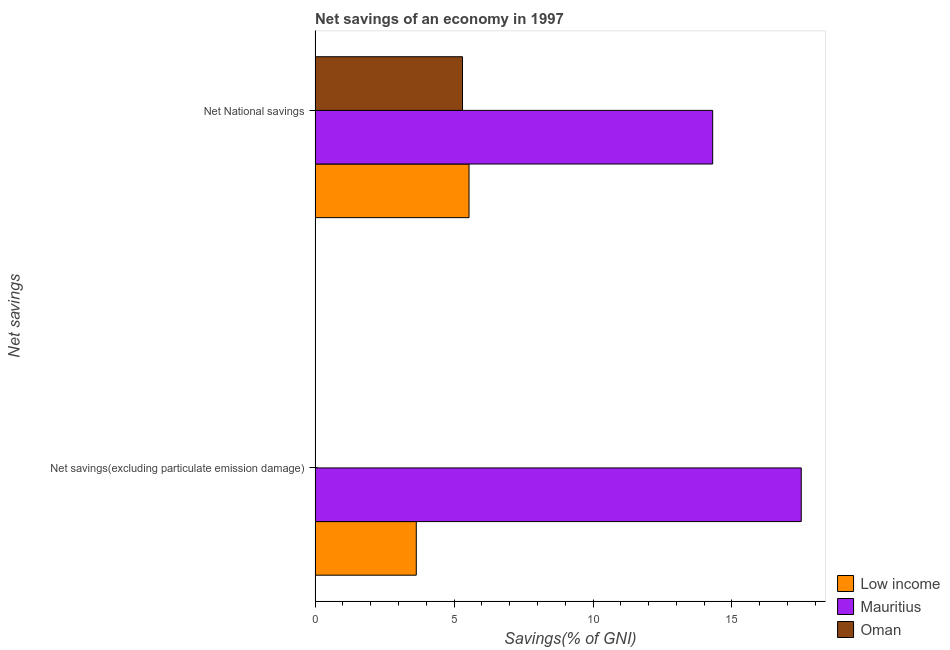How many different coloured bars are there?
Keep it short and to the point. 3. How many groups of bars are there?
Your answer should be very brief. 2. How many bars are there on the 2nd tick from the bottom?
Offer a very short reply. 3. What is the label of the 2nd group of bars from the top?
Offer a very short reply. Net savings(excluding particulate emission damage). What is the net national savings in Oman?
Your answer should be compact. 5.3. Across all countries, what is the maximum net national savings?
Keep it short and to the point. 14.31. Across all countries, what is the minimum net savings(excluding particulate emission damage)?
Your response must be concise. 0. In which country was the net savings(excluding particulate emission damage) maximum?
Your answer should be compact. Mauritius. What is the total net national savings in the graph?
Your answer should be very brief. 25.15. What is the difference between the net national savings in Oman and that in Low income?
Make the answer very short. -0.23. What is the difference between the net savings(excluding particulate emission damage) in Low income and the net national savings in Oman?
Keep it short and to the point. -1.66. What is the average net savings(excluding particulate emission damage) per country?
Provide a short and direct response. 7.04. What is the difference between the net savings(excluding particulate emission damage) and net national savings in Low income?
Provide a succinct answer. -1.9. In how many countries, is the net savings(excluding particulate emission damage) greater than 12 %?
Your response must be concise. 1. What is the ratio of the net national savings in Oman to that in Mauritius?
Your answer should be very brief. 0.37. Is the net savings(excluding particulate emission damage) in Low income less than that in Mauritius?
Offer a terse response. Yes. How many bars are there?
Offer a terse response. 5. Are all the bars in the graph horizontal?
Offer a very short reply. Yes. How many countries are there in the graph?
Offer a very short reply. 3. Are the values on the major ticks of X-axis written in scientific E-notation?
Provide a short and direct response. No. Where does the legend appear in the graph?
Offer a very short reply. Bottom right. How are the legend labels stacked?
Ensure brevity in your answer.  Vertical. What is the title of the graph?
Provide a short and direct response. Net savings of an economy in 1997. Does "Luxembourg" appear as one of the legend labels in the graph?
Offer a terse response. No. What is the label or title of the X-axis?
Provide a short and direct response. Savings(% of GNI). What is the label or title of the Y-axis?
Your answer should be very brief. Net savings. What is the Savings(% of GNI) in Low income in Net savings(excluding particulate emission damage)?
Provide a short and direct response. 3.64. What is the Savings(% of GNI) of Mauritius in Net savings(excluding particulate emission damage)?
Ensure brevity in your answer.  17.49. What is the Savings(% of GNI) in Oman in Net savings(excluding particulate emission damage)?
Keep it short and to the point. 0. What is the Savings(% of GNI) in Low income in Net National savings?
Your response must be concise. 5.54. What is the Savings(% of GNI) of Mauritius in Net National savings?
Your answer should be compact. 14.31. What is the Savings(% of GNI) in Oman in Net National savings?
Offer a terse response. 5.3. Across all Net savings, what is the maximum Savings(% of GNI) in Low income?
Keep it short and to the point. 5.54. Across all Net savings, what is the maximum Savings(% of GNI) of Mauritius?
Ensure brevity in your answer.  17.49. Across all Net savings, what is the maximum Savings(% of GNI) in Oman?
Keep it short and to the point. 5.3. Across all Net savings, what is the minimum Savings(% of GNI) in Low income?
Keep it short and to the point. 3.64. Across all Net savings, what is the minimum Savings(% of GNI) in Mauritius?
Keep it short and to the point. 14.31. Across all Net savings, what is the minimum Savings(% of GNI) of Oman?
Ensure brevity in your answer.  0. What is the total Savings(% of GNI) in Low income in the graph?
Ensure brevity in your answer.  9.18. What is the total Savings(% of GNI) of Mauritius in the graph?
Offer a very short reply. 31.8. What is the total Savings(% of GNI) in Oman in the graph?
Ensure brevity in your answer.  5.3. What is the difference between the Savings(% of GNI) of Low income in Net savings(excluding particulate emission damage) and that in Net National savings?
Your response must be concise. -1.9. What is the difference between the Savings(% of GNI) in Mauritius in Net savings(excluding particulate emission damage) and that in Net National savings?
Your response must be concise. 3.19. What is the difference between the Savings(% of GNI) of Low income in Net savings(excluding particulate emission damage) and the Savings(% of GNI) of Mauritius in Net National savings?
Your answer should be compact. -10.67. What is the difference between the Savings(% of GNI) in Low income in Net savings(excluding particulate emission damage) and the Savings(% of GNI) in Oman in Net National savings?
Provide a short and direct response. -1.66. What is the difference between the Savings(% of GNI) in Mauritius in Net savings(excluding particulate emission damage) and the Savings(% of GNI) in Oman in Net National savings?
Offer a very short reply. 12.19. What is the average Savings(% of GNI) of Low income per Net savings?
Your response must be concise. 4.59. What is the average Savings(% of GNI) in Mauritius per Net savings?
Your answer should be compact. 15.9. What is the average Savings(% of GNI) in Oman per Net savings?
Ensure brevity in your answer.  2.65. What is the difference between the Savings(% of GNI) in Low income and Savings(% of GNI) in Mauritius in Net savings(excluding particulate emission damage)?
Provide a short and direct response. -13.85. What is the difference between the Savings(% of GNI) in Low income and Savings(% of GNI) in Mauritius in Net National savings?
Provide a succinct answer. -8.77. What is the difference between the Savings(% of GNI) in Low income and Savings(% of GNI) in Oman in Net National savings?
Provide a short and direct response. 0.23. What is the difference between the Savings(% of GNI) of Mauritius and Savings(% of GNI) of Oman in Net National savings?
Provide a succinct answer. 9. What is the ratio of the Savings(% of GNI) of Low income in Net savings(excluding particulate emission damage) to that in Net National savings?
Your answer should be very brief. 0.66. What is the ratio of the Savings(% of GNI) in Mauritius in Net savings(excluding particulate emission damage) to that in Net National savings?
Make the answer very short. 1.22. What is the difference between the highest and the second highest Savings(% of GNI) in Low income?
Provide a short and direct response. 1.9. What is the difference between the highest and the second highest Savings(% of GNI) in Mauritius?
Your answer should be very brief. 3.19. What is the difference between the highest and the lowest Savings(% of GNI) in Low income?
Provide a succinct answer. 1.9. What is the difference between the highest and the lowest Savings(% of GNI) in Mauritius?
Offer a terse response. 3.19. What is the difference between the highest and the lowest Savings(% of GNI) in Oman?
Give a very brief answer. 5.3. 